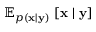Convert formula to latex. <formula><loc_0><loc_0><loc_500><loc_500>\mathbb { E } _ { p ( x | y ) } \, \left [ x | y \right ]</formula> 